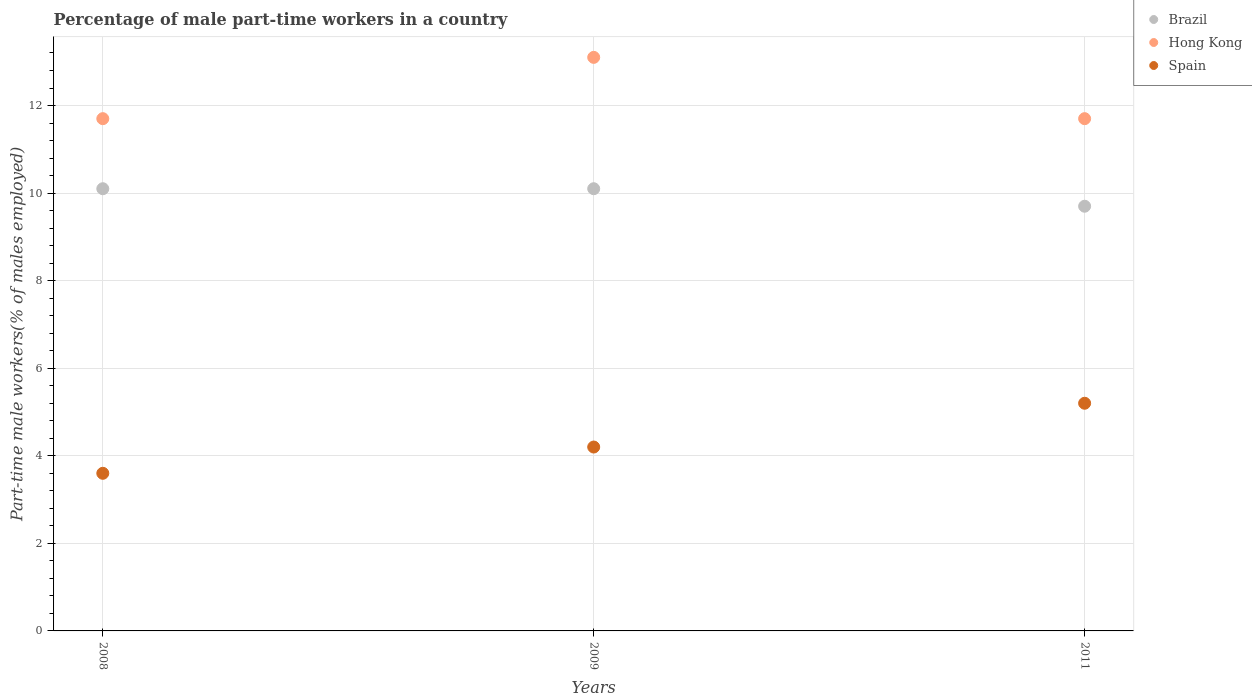Is the number of dotlines equal to the number of legend labels?
Your answer should be compact. Yes. What is the percentage of male part-time workers in Brazil in 2008?
Your response must be concise. 10.1. Across all years, what is the maximum percentage of male part-time workers in Spain?
Your answer should be compact. 5.2. Across all years, what is the minimum percentage of male part-time workers in Hong Kong?
Your response must be concise. 11.7. In which year was the percentage of male part-time workers in Brazil maximum?
Offer a very short reply. 2008. What is the total percentage of male part-time workers in Brazil in the graph?
Give a very brief answer. 29.9. What is the difference between the percentage of male part-time workers in Spain in 2008 and that in 2009?
Offer a terse response. -0.6. What is the difference between the percentage of male part-time workers in Brazil in 2011 and the percentage of male part-time workers in Hong Kong in 2008?
Your answer should be very brief. -2. What is the average percentage of male part-time workers in Brazil per year?
Provide a succinct answer. 9.97. In the year 2008, what is the difference between the percentage of male part-time workers in Hong Kong and percentage of male part-time workers in Brazil?
Provide a succinct answer. 1.6. In how many years, is the percentage of male part-time workers in Spain greater than 4.8 %?
Your answer should be compact. 1. Is the percentage of male part-time workers in Brazil in 2009 less than that in 2011?
Ensure brevity in your answer.  No. Is the difference between the percentage of male part-time workers in Hong Kong in 2009 and 2011 greater than the difference between the percentage of male part-time workers in Brazil in 2009 and 2011?
Make the answer very short. Yes. What is the difference between the highest and the second highest percentage of male part-time workers in Hong Kong?
Your answer should be compact. 1.4. What is the difference between the highest and the lowest percentage of male part-time workers in Hong Kong?
Provide a succinct answer. 1.4. Is the percentage of male part-time workers in Hong Kong strictly greater than the percentage of male part-time workers in Spain over the years?
Your answer should be compact. Yes. How many dotlines are there?
Ensure brevity in your answer.  3. How many years are there in the graph?
Your answer should be compact. 3. What is the difference between two consecutive major ticks on the Y-axis?
Keep it short and to the point. 2. Are the values on the major ticks of Y-axis written in scientific E-notation?
Your answer should be very brief. No. Does the graph contain any zero values?
Keep it short and to the point. No. Where does the legend appear in the graph?
Your response must be concise. Top right. How many legend labels are there?
Keep it short and to the point. 3. What is the title of the graph?
Keep it short and to the point. Percentage of male part-time workers in a country. Does "Mongolia" appear as one of the legend labels in the graph?
Offer a terse response. No. What is the label or title of the X-axis?
Provide a short and direct response. Years. What is the label or title of the Y-axis?
Your answer should be very brief. Part-time male workers(% of males employed). What is the Part-time male workers(% of males employed) in Brazil in 2008?
Your response must be concise. 10.1. What is the Part-time male workers(% of males employed) of Hong Kong in 2008?
Provide a succinct answer. 11.7. What is the Part-time male workers(% of males employed) in Spain in 2008?
Your answer should be very brief. 3.6. What is the Part-time male workers(% of males employed) in Brazil in 2009?
Provide a succinct answer. 10.1. What is the Part-time male workers(% of males employed) of Hong Kong in 2009?
Ensure brevity in your answer.  13.1. What is the Part-time male workers(% of males employed) in Spain in 2009?
Provide a short and direct response. 4.2. What is the Part-time male workers(% of males employed) of Brazil in 2011?
Offer a very short reply. 9.7. What is the Part-time male workers(% of males employed) of Hong Kong in 2011?
Give a very brief answer. 11.7. What is the Part-time male workers(% of males employed) in Spain in 2011?
Offer a terse response. 5.2. Across all years, what is the maximum Part-time male workers(% of males employed) of Brazil?
Your answer should be very brief. 10.1. Across all years, what is the maximum Part-time male workers(% of males employed) of Hong Kong?
Provide a short and direct response. 13.1. Across all years, what is the maximum Part-time male workers(% of males employed) of Spain?
Keep it short and to the point. 5.2. Across all years, what is the minimum Part-time male workers(% of males employed) in Brazil?
Offer a terse response. 9.7. Across all years, what is the minimum Part-time male workers(% of males employed) in Hong Kong?
Keep it short and to the point. 11.7. Across all years, what is the minimum Part-time male workers(% of males employed) of Spain?
Your answer should be very brief. 3.6. What is the total Part-time male workers(% of males employed) of Brazil in the graph?
Provide a succinct answer. 29.9. What is the total Part-time male workers(% of males employed) of Hong Kong in the graph?
Your answer should be compact. 36.5. What is the total Part-time male workers(% of males employed) of Spain in the graph?
Provide a short and direct response. 13. What is the difference between the Part-time male workers(% of males employed) in Brazil in 2008 and that in 2011?
Offer a very short reply. 0.4. What is the difference between the Part-time male workers(% of males employed) in Spain in 2008 and that in 2011?
Your answer should be very brief. -1.6. What is the difference between the Part-time male workers(% of males employed) in Hong Kong in 2009 and that in 2011?
Your answer should be very brief. 1.4. What is the difference between the Part-time male workers(% of males employed) of Brazil in 2008 and the Part-time male workers(% of males employed) of Hong Kong in 2009?
Give a very brief answer. -3. What is the difference between the Part-time male workers(% of males employed) in Brazil in 2008 and the Part-time male workers(% of males employed) in Spain in 2009?
Give a very brief answer. 5.9. What is the difference between the Part-time male workers(% of males employed) in Hong Kong in 2008 and the Part-time male workers(% of males employed) in Spain in 2009?
Your answer should be very brief. 7.5. What is the difference between the Part-time male workers(% of males employed) in Brazil in 2008 and the Part-time male workers(% of males employed) in Hong Kong in 2011?
Make the answer very short. -1.6. What is the difference between the Part-time male workers(% of males employed) in Brazil in 2008 and the Part-time male workers(% of males employed) in Spain in 2011?
Keep it short and to the point. 4.9. What is the difference between the Part-time male workers(% of males employed) of Brazil in 2009 and the Part-time male workers(% of males employed) of Hong Kong in 2011?
Provide a short and direct response. -1.6. What is the average Part-time male workers(% of males employed) of Brazil per year?
Your response must be concise. 9.97. What is the average Part-time male workers(% of males employed) of Hong Kong per year?
Keep it short and to the point. 12.17. What is the average Part-time male workers(% of males employed) in Spain per year?
Your answer should be very brief. 4.33. In the year 2008, what is the difference between the Part-time male workers(% of males employed) of Brazil and Part-time male workers(% of males employed) of Hong Kong?
Your answer should be very brief. -1.6. In the year 2009, what is the difference between the Part-time male workers(% of males employed) in Brazil and Part-time male workers(% of males employed) in Hong Kong?
Make the answer very short. -3. In the year 2011, what is the difference between the Part-time male workers(% of males employed) of Brazil and Part-time male workers(% of males employed) of Spain?
Offer a terse response. 4.5. In the year 2011, what is the difference between the Part-time male workers(% of males employed) in Hong Kong and Part-time male workers(% of males employed) in Spain?
Provide a short and direct response. 6.5. What is the ratio of the Part-time male workers(% of males employed) in Hong Kong in 2008 to that in 2009?
Offer a terse response. 0.89. What is the ratio of the Part-time male workers(% of males employed) of Spain in 2008 to that in 2009?
Keep it short and to the point. 0.86. What is the ratio of the Part-time male workers(% of males employed) of Brazil in 2008 to that in 2011?
Ensure brevity in your answer.  1.04. What is the ratio of the Part-time male workers(% of males employed) of Hong Kong in 2008 to that in 2011?
Provide a succinct answer. 1. What is the ratio of the Part-time male workers(% of males employed) of Spain in 2008 to that in 2011?
Offer a terse response. 0.69. What is the ratio of the Part-time male workers(% of males employed) in Brazil in 2009 to that in 2011?
Provide a short and direct response. 1.04. What is the ratio of the Part-time male workers(% of males employed) of Hong Kong in 2009 to that in 2011?
Your answer should be very brief. 1.12. What is the ratio of the Part-time male workers(% of males employed) in Spain in 2009 to that in 2011?
Offer a terse response. 0.81. What is the difference between the highest and the second highest Part-time male workers(% of males employed) of Hong Kong?
Provide a short and direct response. 1.4. 